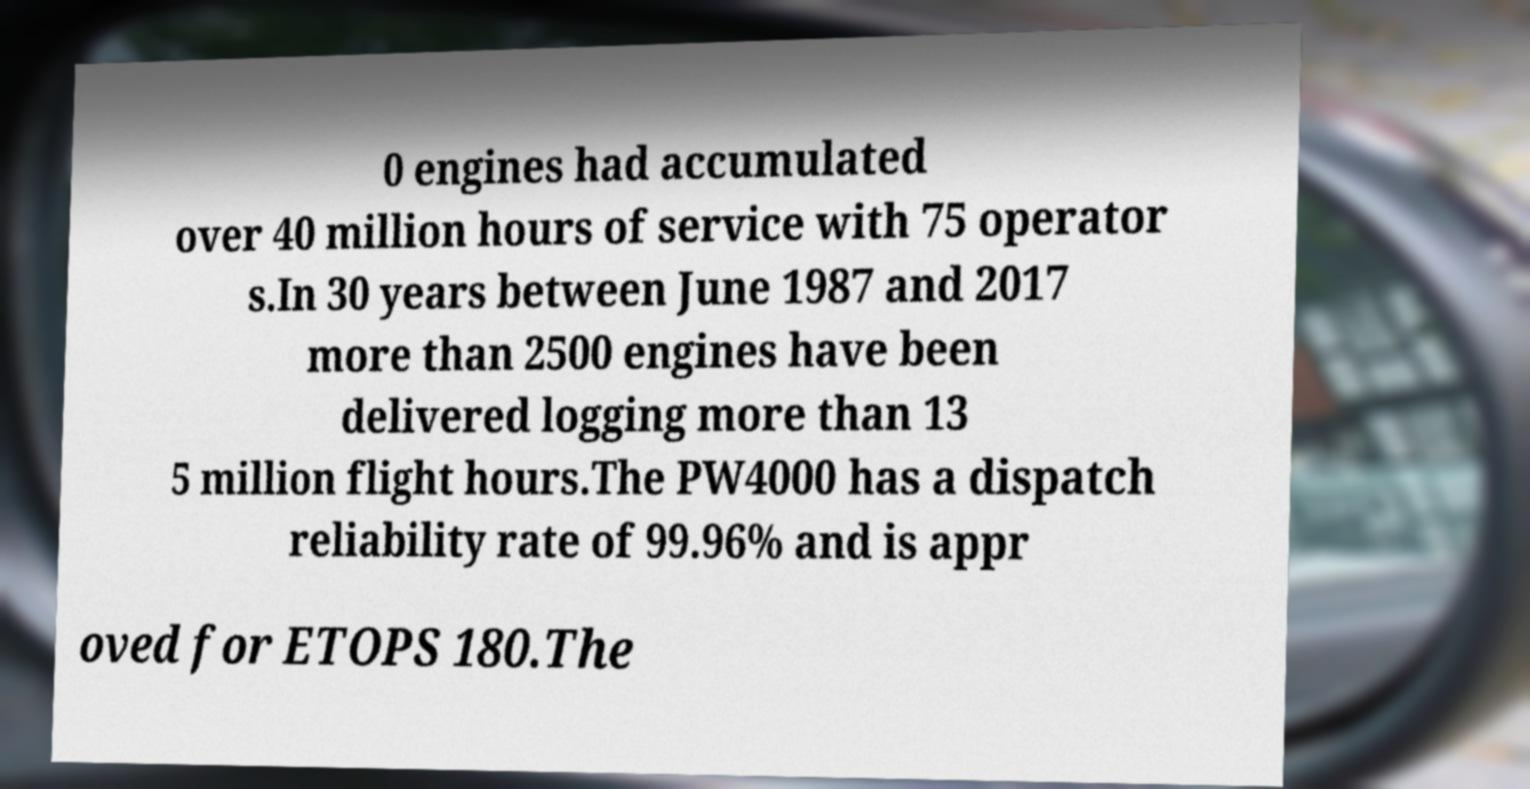What messages or text are displayed in this image? I need them in a readable, typed format. 0 engines had accumulated over 40 million hours of service with 75 operator s.In 30 years between June 1987 and 2017 more than 2500 engines have been delivered logging more than 13 5 million flight hours.The PW4000 has a dispatch reliability rate of 99.96% and is appr oved for ETOPS 180.The 